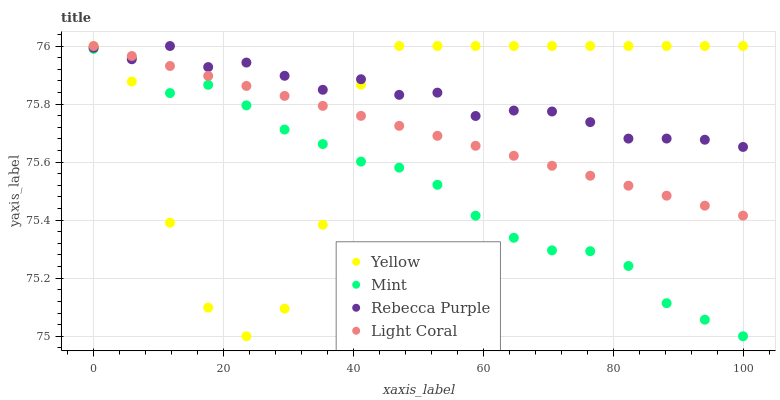Does Mint have the minimum area under the curve?
Answer yes or no. Yes. Does Rebecca Purple have the maximum area under the curve?
Answer yes or no. Yes. Does Rebecca Purple have the minimum area under the curve?
Answer yes or no. No. Does Mint have the maximum area under the curve?
Answer yes or no. No. Is Light Coral the smoothest?
Answer yes or no. Yes. Is Yellow the roughest?
Answer yes or no. Yes. Is Mint the smoothest?
Answer yes or no. No. Is Mint the roughest?
Answer yes or no. No. Does Mint have the lowest value?
Answer yes or no. Yes. Does Rebecca Purple have the lowest value?
Answer yes or no. No. Does Yellow have the highest value?
Answer yes or no. Yes. Does Mint have the highest value?
Answer yes or no. No. Is Mint less than Light Coral?
Answer yes or no. Yes. Is Light Coral greater than Mint?
Answer yes or no. Yes. Does Mint intersect Yellow?
Answer yes or no. Yes. Is Mint less than Yellow?
Answer yes or no. No. Is Mint greater than Yellow?
Answer yes or no. No. Does Mint intersect Light Coral?
Answer yes or no. No. 